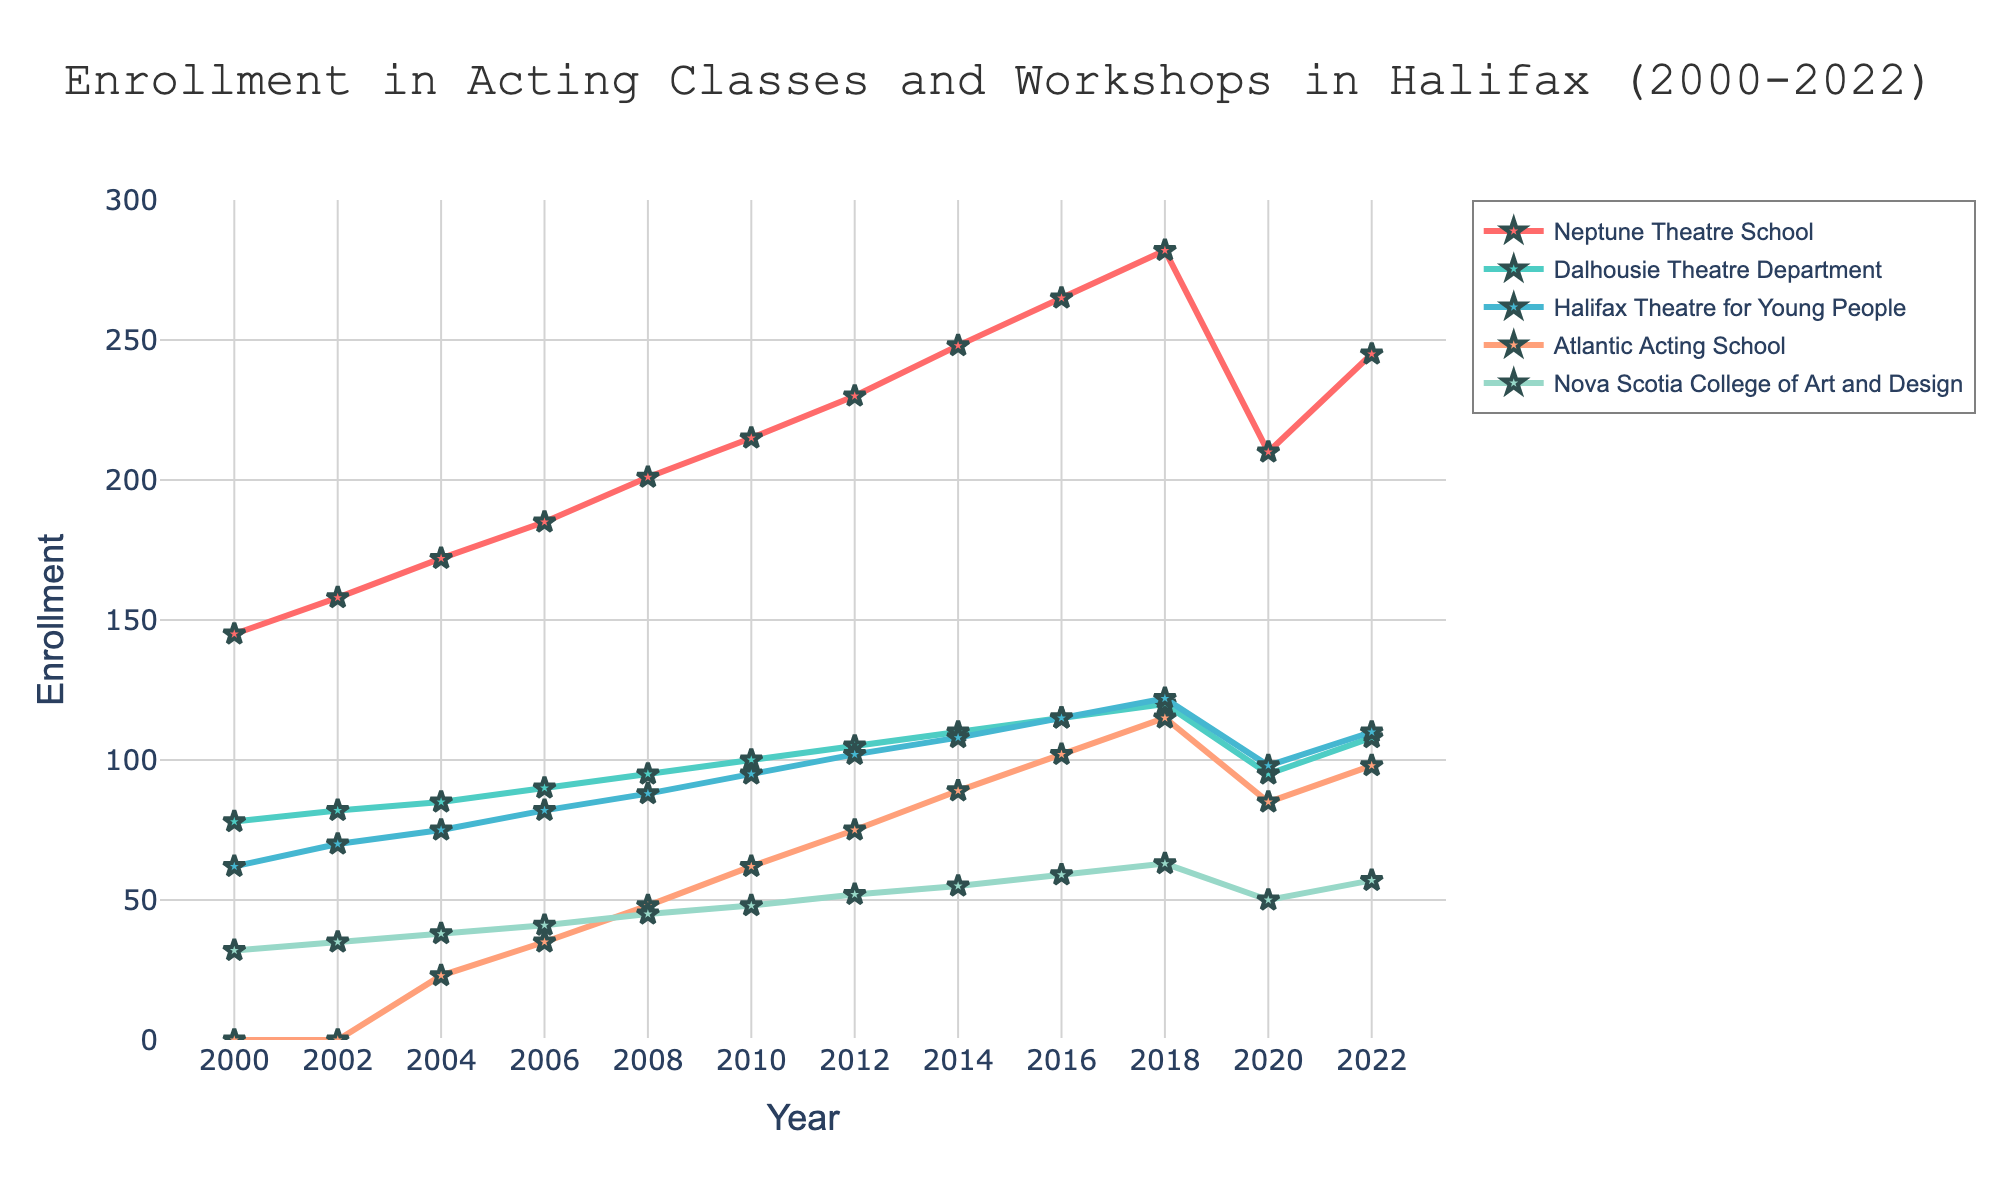How has the enrollment trend for the Neptune Theatre School changed from 2000 to 2022? First, observe Neptune Theatre School’s line from 2000 to 2022. It starts at 145 in 2000 and increases mostly steadily, except for a notable drop between 2018 (282) and 2020 (210), then rises again to 245 in 2022.
Answer: It increased overall, with fluctuations Which school had the highest enrollment in 2022? Look at the 2022 data points for all schools. Neptune Theatre School (245) has the highest enrollment.
Answer: Neptune Theatre School Compare the enrollment trends of Dalhousie Theatre Department and NSCAD from 2000 to 2022. Observe the lines for Dalhousie Theatre Department and Nova Scotia College of Art and Design (NSCAD). Dalhousie increases steadily from 78 to 108, while NSCAD also increases but at a slightly steadier rate from 32 to 57. Both have minor dips around 2020.
Answer: Dalhousie steadily increases, while NSCAD has slower growth How did the Halifax Theatre for Young People enrollment change between 2018 and 2020? Check the values for Halifax Theatre for Young People in 2018 (122) and 2020 (98). The enrollment decreased by 24.
Answer: Decreased by 24 Which school had the most stable enrollment trend over the years? Look for the school with the least variation in the height of its line. Dalhousie Theatre Department shows a relatively consistent and steady rise without sharp fluctuations.
Answer: Dalhousie Theatre Department What was the enrollment difference between Neptune Theatre School and Atlantic Acting School in 2006? Find the enrollment for both schools in 2006: Neptune Theatre School (185) and Atlantic Acting School (35). Subtract 35 from 185 to get the difference, which is 150.
Answer: 150 Between which years did the Neptune Theatre School’s enrollment drop the most and by how much? Looking at the enrollment values of Neptune Theatre School, the biggest drop occurs between 2018 (282) and 2020 (210), a difference of 72.
Answer: 2018 and 2020, 72 Calculate the average enrollment trend for NSCAD from 2000 to 2022. Sum the enrollment values for NSCAD from 2000 to 2022 and divide by the number of data points (5). The values are 32, 35, 38, 41, 45, 48, 52, 55, 59, 63, 50, 57, totaling 575; hence, 575/12 ≈ 48.
Answer: 48 Which year saw the highest total enrollment across all schools? Sum the enrollment values for all schools each year and compare. The year 2018 has the highest total: 282 (Neptune) + 120 (Dalhousie) + 122 (Halifax Theatre) + 115 (Atlantic Acting) + 63 (NSCAD) = 702.
Answer: 2018 What percentage of total enrollment did the Atlantic Acting School have in 2016? First, calculate the total enrollment in 2016: 265 (Neptune) + 115 (Dalhousie) + 115 (Halifax Theatre) + 102 (Atlantic Acting) + 59 (NSCAD) = 656. Then, find the percentage: (102 / 656) * 100 ≈ 15.55%.
Answer: 15.55% 